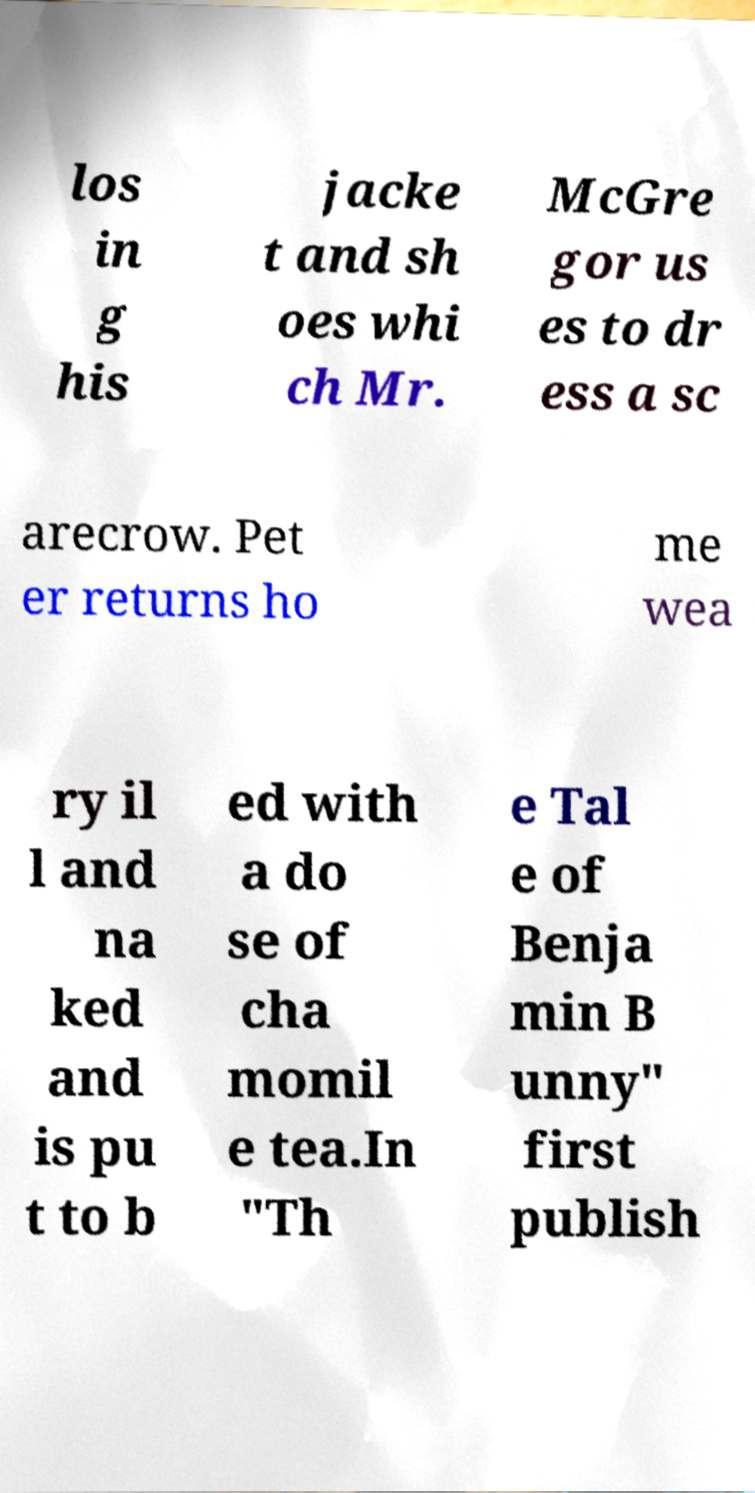Please identify and transcribe the text found in this image. los in g his jacke t and sh oes whi ch Mr. McGre gor us es to dr ess a sc arecrow. Pet er returns ho me wea ry il l and na ked and is pu t to b ed with a do se of cha momil e tea.In "Th e Tal e of Benja min B unny" first publish 